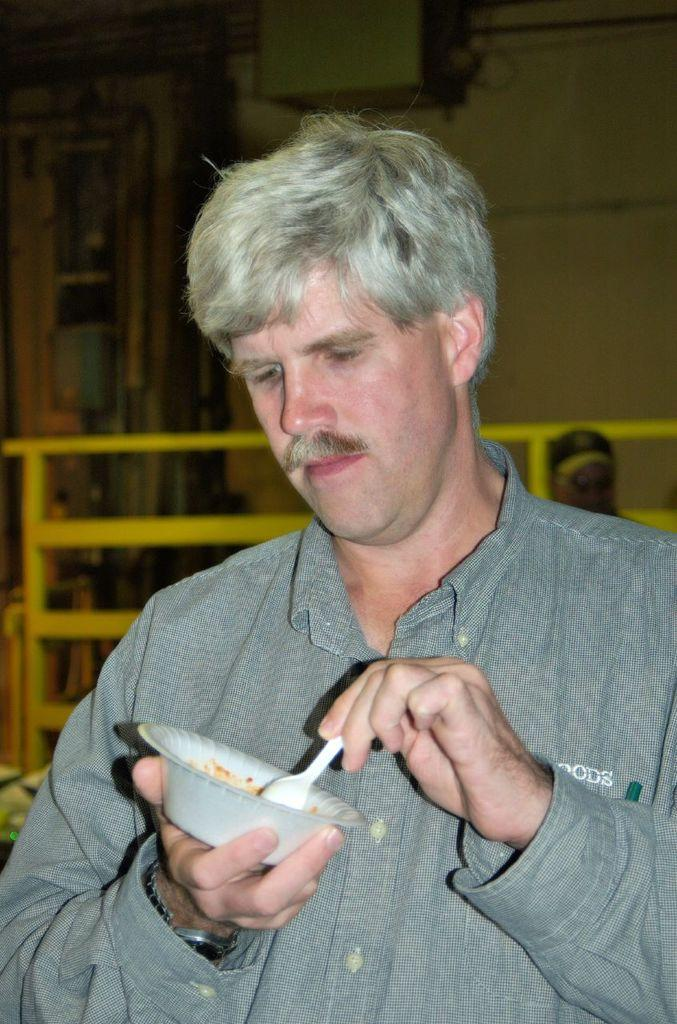What is the man in the center of the image doing? The man is standing in the center of the image and holding a bowl and a spoon. What objects is the man holding in the image? The man is holding a bowl and a spoon in the image. What can be seen in the background of the image? There is a fence, a wall, and another person visible in the background of the image. How many clovers are growing in the tub in the image? There is no tub or clover present in the image. 